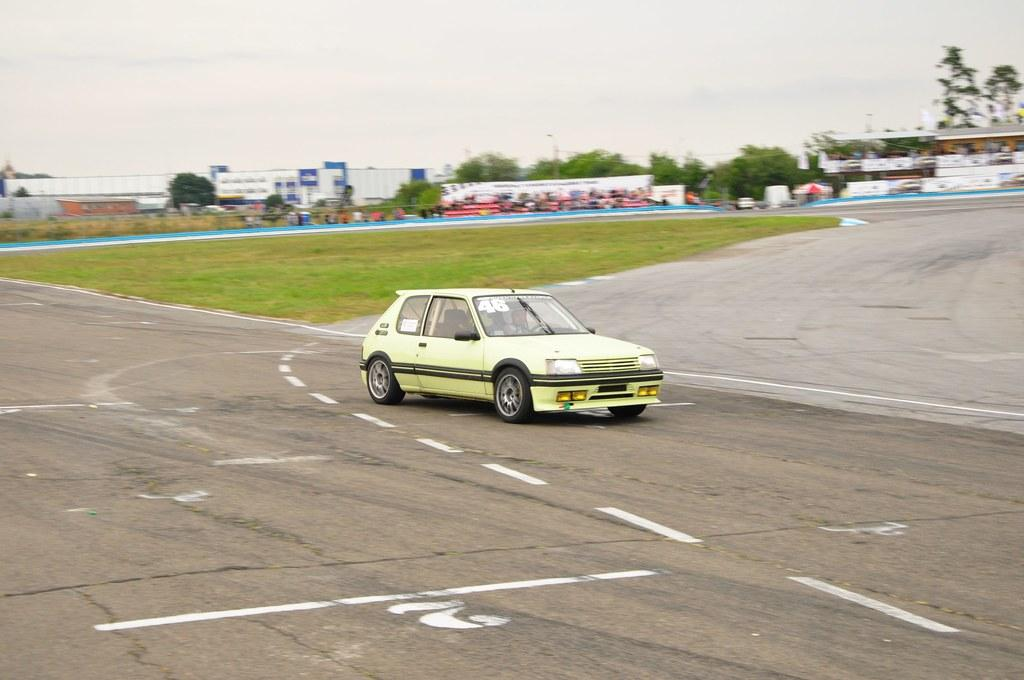What is the main subject of the image? The main subject of the image is a car. What is the car doing in the image? The car is moving on the road in the image. Can you describe the color of the car? The car is green in color. What can be seen in the background of the image? There are buildings in the background of the image. How would you describe the weather based on the image? The sky is cloudy in the image, which suggests a partly cloudy or overcast day. Where is the basin located in the image? There is no basin present in the image; it features a moving green car on the road with buildings in the background and a cloudy sky. What type of channel can be seen in the image? There is no channel present in the image. 